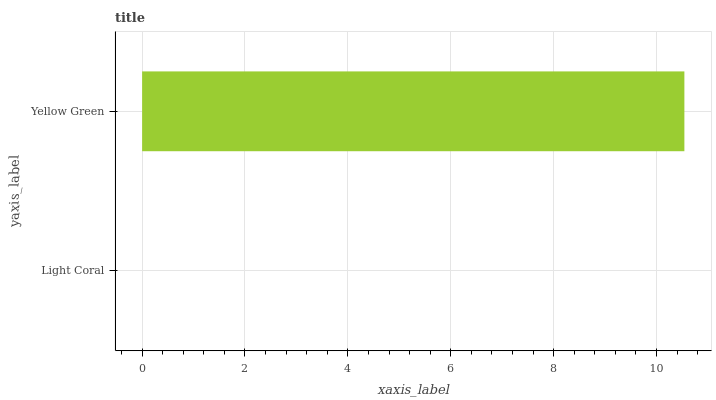Is Light Coral the minimum?
Answer yes or no. Yes. Is Yellow Green the maximum?
Answer yes or no. Yes. Is Yellow Green the minimum?
Answer yes or no. No. Is Yellow Green greater than Light Coral?
Answer yes or no. Yes. Is Light Coral less than Yellow Green?
Answer yes or no. Yes. Is Light Coral greater than Yellow Green?
Answer yes or no. No. Is Yellow Green less than Light Coral?
Answer yes or no. No. Is Yellow Green the high median?
Answer yes or no. Yes. Is Light Coral the low median?
Answer yes or no. Yes. Is Light Coral the high median?
Answer yes or no. No. Is Yellow Green the low median?
Answer yes or no. No. 